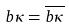Convert formula to latex. <formula><loc_0><loc_0><loc_500><loc_500>b \kappa = \overline { b \kappa }</formula> 